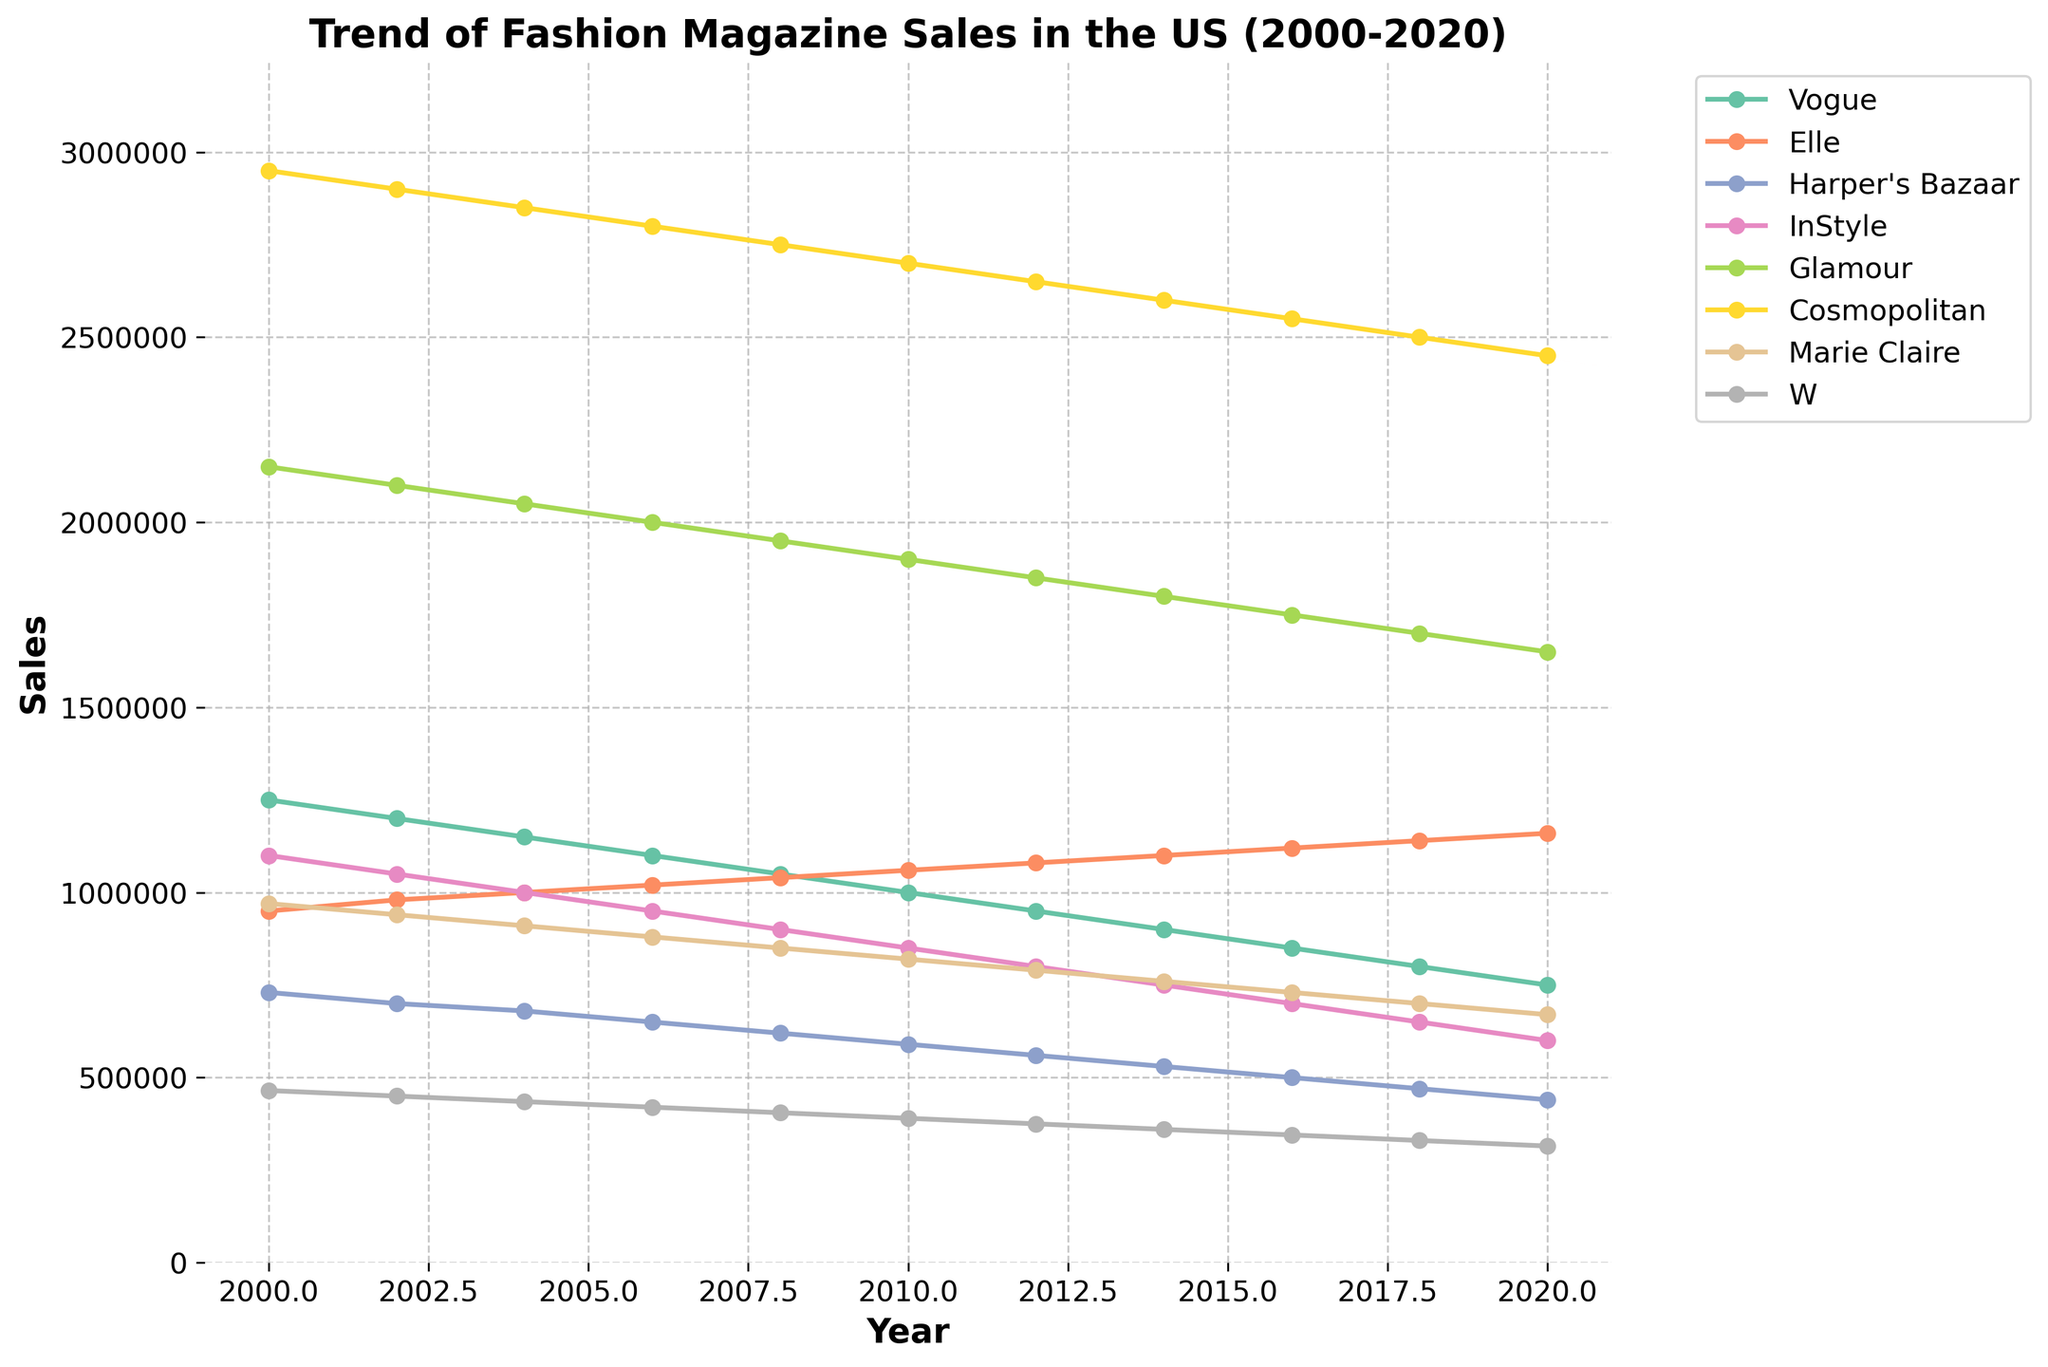what is the trend of sales for Vogue? First, locate the line representing Vogue in the chart. Observe that Vogue's sales decrease from 2000 to 2020, starting at 1,250,000 copies sold in 2000 and dropping gradually to 750,000 copies by 2020.
Answer: Vogue's sales show a decreasing trend which magazine had the highest sales in 2008? Look for the highest point on the graph for the year 2008. Find the magazine that corresponds to the highest y-value. In 2008, Glamour had the highest sales with approximately 1,950,000 copies sold.
Answer: Glamour compare the sales of Vogue and Elle in 2020 Locate the data points for Vogue and Elle in the year 2020. Vogue sold about 750,000 copies, while Elle sold approximately 1,160,000 copies. Elle had higher sales in 2020.
Answer: Elle had higher sales how much did Glamour's sales decrease from 2000 to 2020? Glamour's sales in 2000 were 2,150,000 copies and decreased to 1,650,000 copies in 2020. Calculate the difference: 2,150,000 - 1,650,000 = 500,000.
Answer: 500,000 copies what is the average sales of InStyle from 2000 to 2020? Sum up InStyle's sales from 2000 to 2020 and divide by the number of years (11). Sales are 1,100,000 in 2000 to 600,000 in 2020. Average = (11,000,000 / 11) = 1,000,000.
Answer: 1,000,000 copies which magazine had steady sales over the period? Identify the magazine whose sales line is relatively flat compared to others. Marie Claire's sales remain roughly consistent, peaking slightly at around 1,140,000 in later years but generally exhibiting minimal fluctuation.
Answer: Marie Claire what was the sales difference between the highest and lowest selling magazine in 2016? Identify the highest and lowest selling magazines in 2016. Cosmopolitan sold about 2,550,000 copies, W sold about 345,000. Difference = 2,550,000 - 345,000 = 2,205,000 copies.
Answer: 2,205,000 copies which magazine showed the sharpest decline from 2000 to 2020? Look for the magazine whose sales line has the steepest downward slope. Harper's Bazaar started at 730,000 in 2000 and went down to 440,000 in 2020, showing a steep decline.
Answer: Harper’s Bazaar what is the percentage drop in sales of W from 2000 to 2020? Calculate W's percentage drop: Initial sales = 465,000, Final sales = 315,000. Percentage drop = ((465,000 - 315,000)/465,000) * 100. Approximately 32.26%.
Answer: ~32.26% which year's sales were the closest between Vogue and Glamour? Compare the sales data year by year to find the smallest difference between Vogue and Glamour. In 2014, their sales were 900,000 and 1,800,000 respectively, with the smallest difference of 900,000.
Answer: 2014 